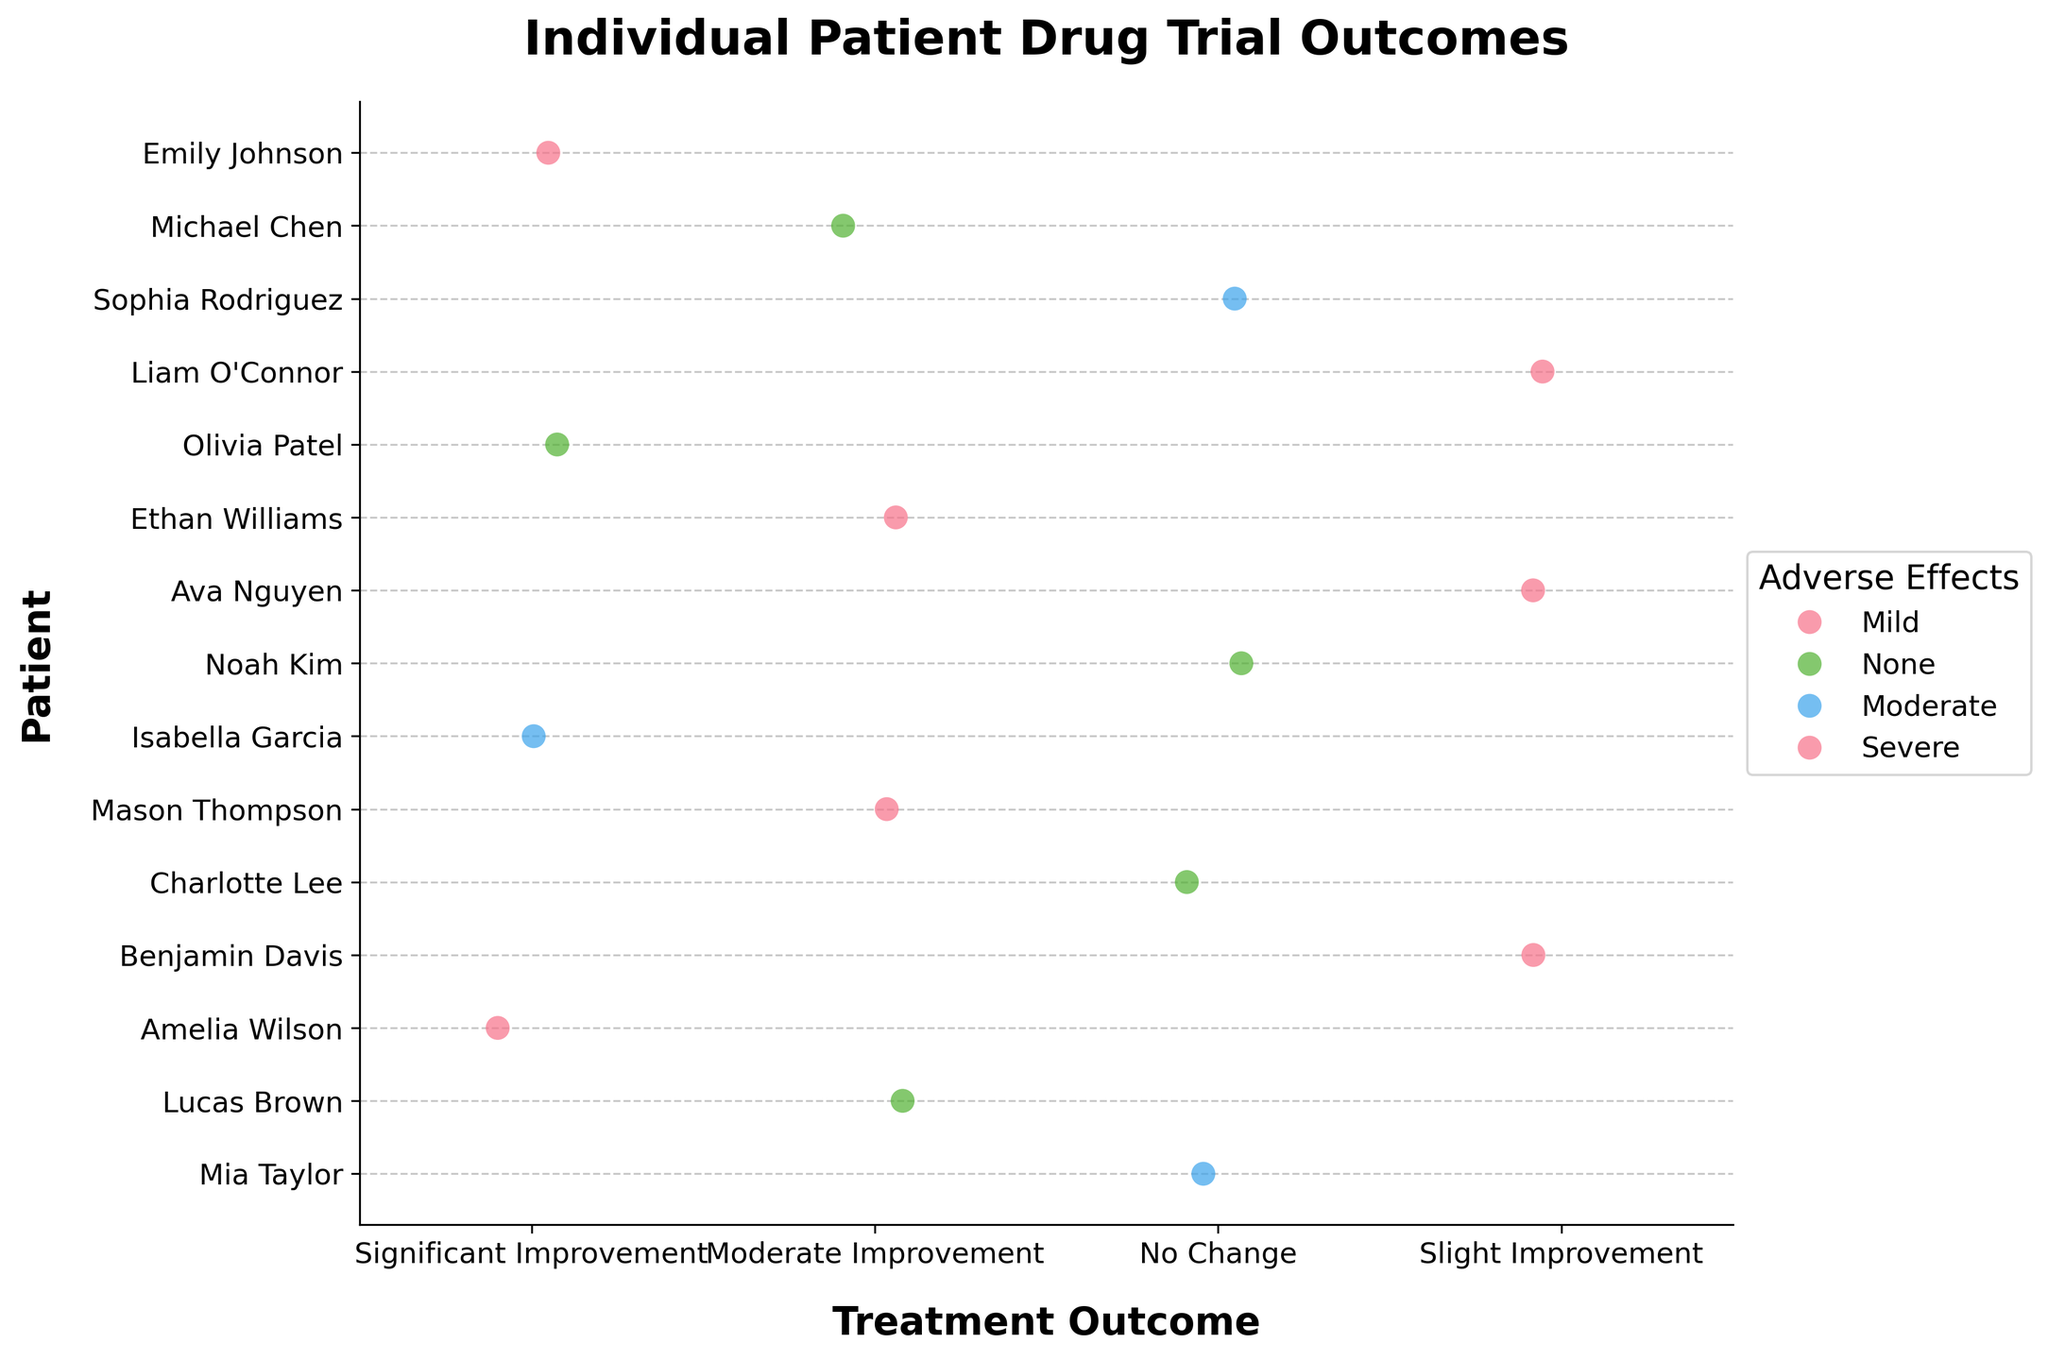What's the title of the plot? The title is located at the top of the figure and provides an overview of what the plot represents. Here, it is "Individual Patient Drug Trial Outcomes".
Answer: Individual Patient Drug Trial Outcomes How many patients experienced "Moderate Improvement" as their treatment outcome? Look at the x-axis labeled "Treatment Outcome" and count how many data points fall under "Moderate Improvement". There are 4 data points at this location.
Answer: 4 Which treatment outcome had the most patients with "No Adverse Effects"? Identify the treatment outcomes along the x-axis and the points with the "None" hue in the legend. "No Adverse Effects" is indicated by the appropriately colored points. There are 3 patients under "No Change" with no adverse effects.
Answer: No Change How many patients experienced "Significant Improvement" and had "Mild" adverse effects? Locate the "Significant Improvement" category on the x-axis and count the data points having a color corresponding to "Mild" adverse effects as per the legend. There are 2 such data points.
Answer: 2 What is the most common adverse effect among the patients who experienced "Slight Improvement"? Count the number of patients in the "Slight Improvement" category and match with colors. "Mild" adverse effects have the most data points (2).
Answer: Mild Compare the number of patients with "Moderate Improvement" and "No Adverse Effects" versus those with "Moderate Improvement" and "Severe" adverse effects. Which group is larger? Identify "Moderate Improvement" on the x-axis and count how many patients have "None" adverse effects compared to "Severe" adverse effects. There are 2 patients with "None" and 1 with "Severe".
Answer: None adverse effects Are there more patients with "Severe" or "Mild" adverse effects in total? Count the total number of data points colored for "Severe" and "Mild" adverse effects in the legend. "Severe" has 2 data points, and "Mild" has 3 data points.
Answer: Mild What's the proportion of patients who had "No Change" in treatment outcome to total patients? There are 3 patients with "No Change" out of a total of 15 patients. The proportion is 3/15.
Answer: 3/15 How many different adverse effect categories are represented in the plot? The legend indicates the number of adverse effect categories. There are three categories: Mild, None, and Moderate.
Answer: 3 Which patient had "Severe" adverse effects and "Moderate Improvement"? Locate the data point under "Moderate Improvement" with the "Severe" hue according to the legend. The patient is Ethan Williams.
Answer: Ethan Williams 